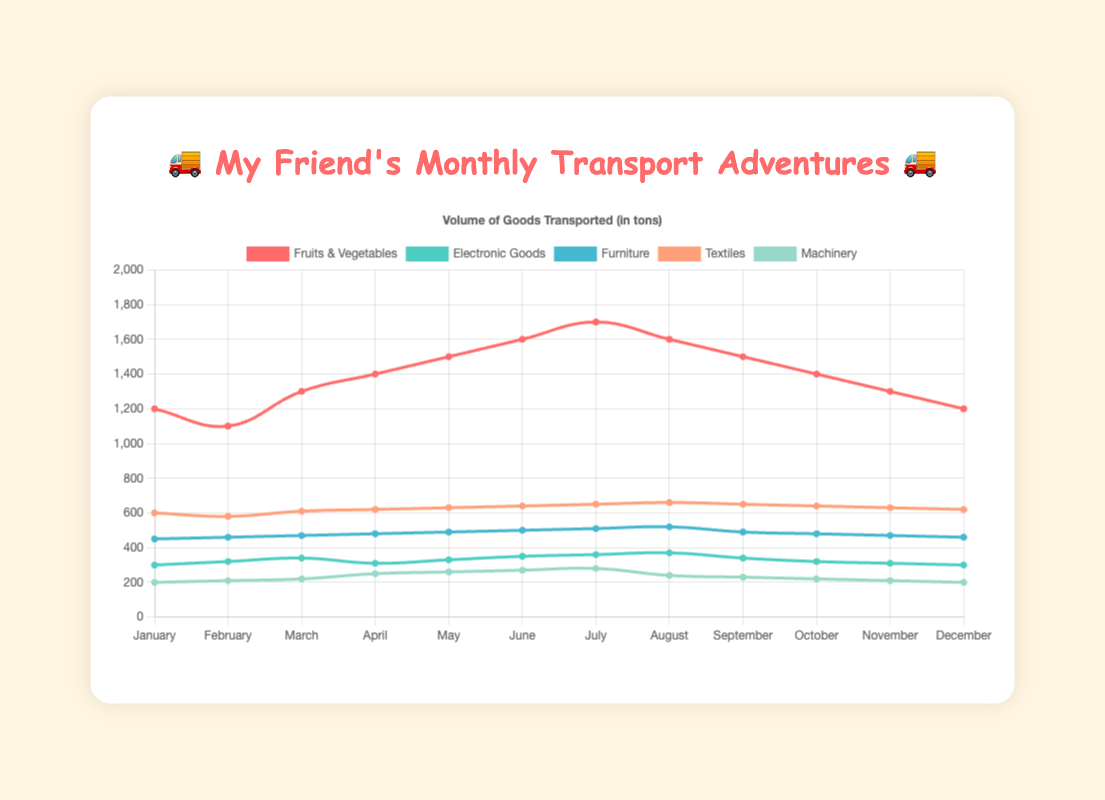Which type of goods has the highest volume transported in June? The figure shows the volume of goods for each type in each month. In June, fruits and vegetables have the highest volume, marked by the tallest line segment.
Answer: Fruits & Vegetables What is the average volume of electronic goods transported from January to December? To calculate the average, sum all electronic goods volumes for each month and divide by 12. (300 + 320 + 340 + 310 + 330 + 350 + 360 + 370 + 340 + 320 + 310 + 300) / 12 = 325
Answer: 325 How does the volume of machinery transported in July compare to April? The figure shows the count of machinery transported for each month. July's value is 280 and April's is 250. 280 is greater than 250.
Answer: July > April Which month has the lowest volume of textiles transported? The figure indicates textile transport volumes with a line for each month. February shows the lowest with 580 tons.
Answer: February Is there a month where the volume of furniture transported is higher than textiles? The figures display both lines for furniture and textiles over months, indicating that at no point does furniture surpass textiles' volumes.
Answer: No What is the total volume of fruits and vegetables transported from May to August? Sum the volumes from May to August. (1500 + 1600 + 1700 + 1600) = 6400
Answer: 6400 What color represents the electronic goods on the plot? The plot uses different colors for each type of goods. The electronic goods line is represented by green.
Answer: Green What is the range of volume for machinery transported throughout the year? Find the difference between the maximum and minimum volumes of machinery from the data. The highest is 280 (July), and the lowest is 200 (January and December). 280 - 200 = 80.
Answer: 80 In which month do fruits and vegetables see their peak volume, and what is that volume? By looking at the plot, the tallest point for fruits and vegetables is in July with a volume of 1700.
Answer: July, 1700 